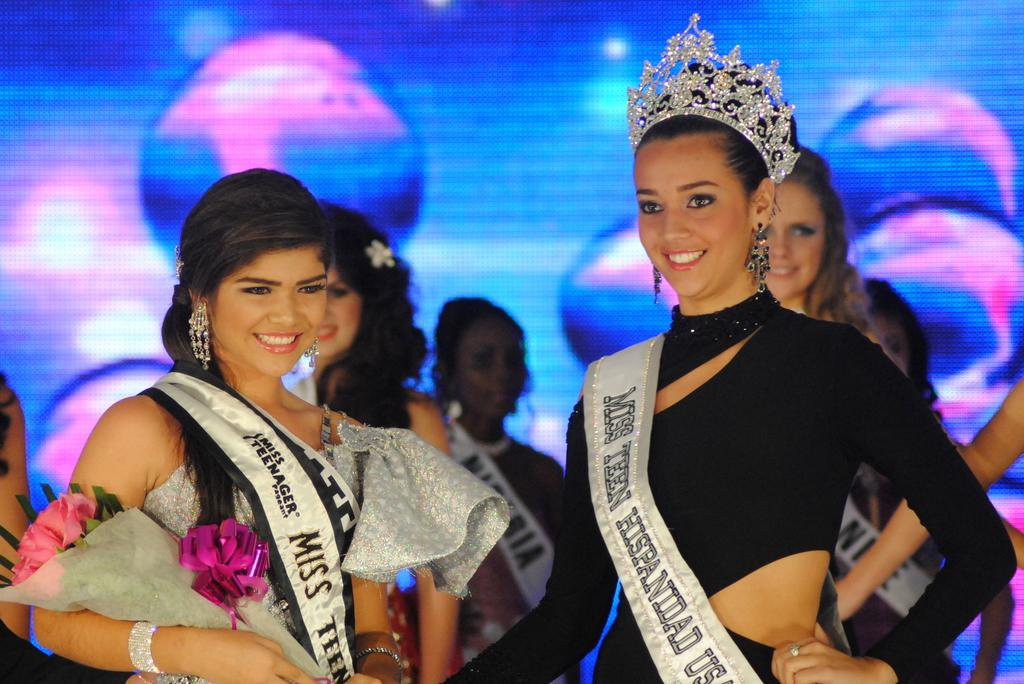<image>
Provide a brief description of the given image. contestants in a miss teen hispanidad us pagent 